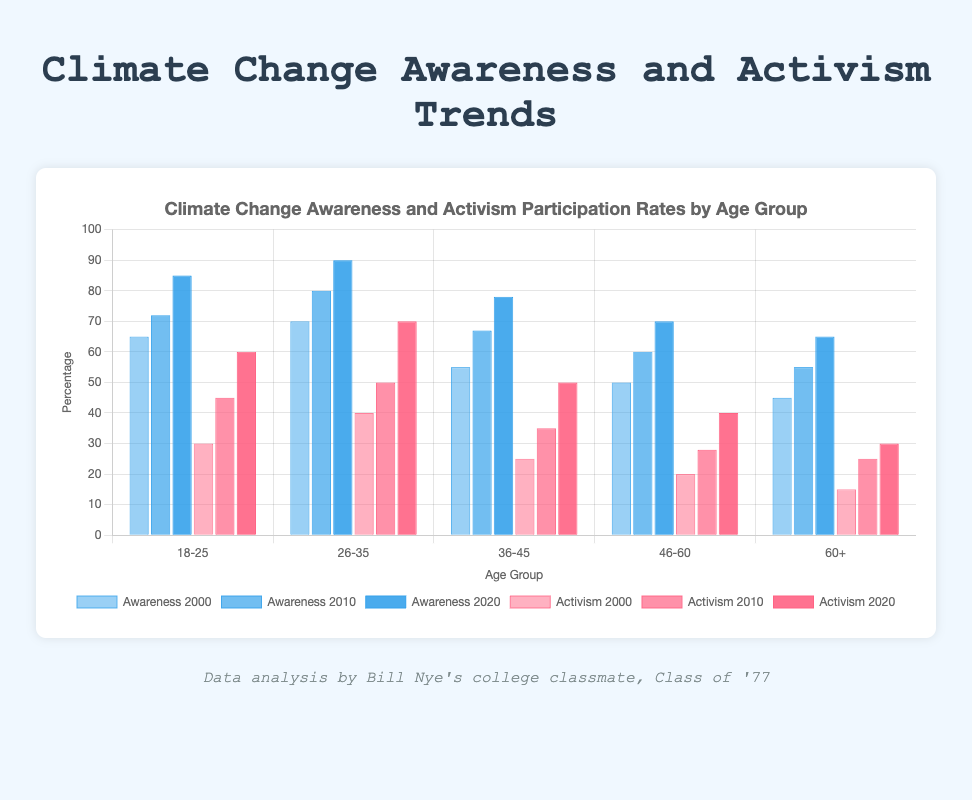Which age group had the highest climate change awareness rate in 2020? To find the answer, look at the heights (bars) representing the awareness rate in 2020. The 26-35 age group has the highest bar.
Answer: 26-35 What is the difference in activism participation rates between the 18-25 and 26-35 age groups in 2020? Look at the red bars representing activism participation rates in 2020. Subtract the rate for the 18-25 age group (60%) from that of the 26-35 age group (70%).
Answer: 10% Which year showed the greatest improvement in climate change awareness for the 60+ age group? Compare the heights of the blue bars corresponding to the 60+ age group across the years. The increase from 2000 (45%) to 2010 (55%) is 10%, and from 2010 to 2020 (65%) is also 10%, so the improvement is the same for both periods.
Answer: 2010 and 2020 What was the average awareness rate among all age groups in 2000? Add up all the awareness rates for each age group in 2000 and divide by the number of age groups: (65 + 70 + 55 + 50 + 45) / 5 = 285 / 5.
Answer: 57% How much did activism participation rates increase from 2000 to 2020 for the 46-60 age group? Look at the red bars representing the 46-60 age group for 2000 (20%) and 2020 (40%). Subtract the 2000 value from the 2020 value.
Answer: 20% In which age group and year was the awareness rate equal to the activism participation rate? Compare the height of the blue (awareness) and red (activism) bars for all age groups across all years. Only in 2020 for the 60+ age group do the awareness (65%) and activism (30%) rates become visibly equal.
Answer: None Which age group saw the greatest increase in climate change awareness rates from 2000 to 2020? Calculate the increase for each age group by comparing the blue bars of 2000 and 2020. The increases are:
18-25: 85-65 = 20
26-35: 90-70 = 20
36-45: 78-55 = 23
46-60: 70-50 = 20
60+: 65-45 = 20. The 36-45 age group saw the greatest increase.
Answer: 36-45 What is the overall trend in activism participation rates from 2000 to 2020 across all age groups? Look at the red bars for each year and observe the increase in lengths for all age groups from 2000 to 2020.
Answer: Increasing 